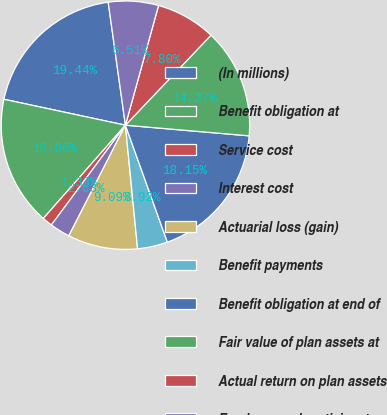Convert chart. <chart><loc_0><loc_0><loc_500><loc_500><pie_chart><fcel>(In millions)<fcel>Benefit obligation at<fcel>Service cost<fcel>Interest cost<fcel>Actuarial loss (gain)<fcel>Benefit payments<fcel>Benefit obligation at end of<fcel>Fair value of plan assets at<fcel>Actual return on plan assets<fcel>Employer and participant<nl><fcel>19.44%<fcel>16.86%<fcel>1.33%<fcel>2.63%<fcel>9.09%<fcel>3.92%<fcel>18.15%<fcel>14.27%<fcel>7.8%<fcel>6.51%<nl></chart> 